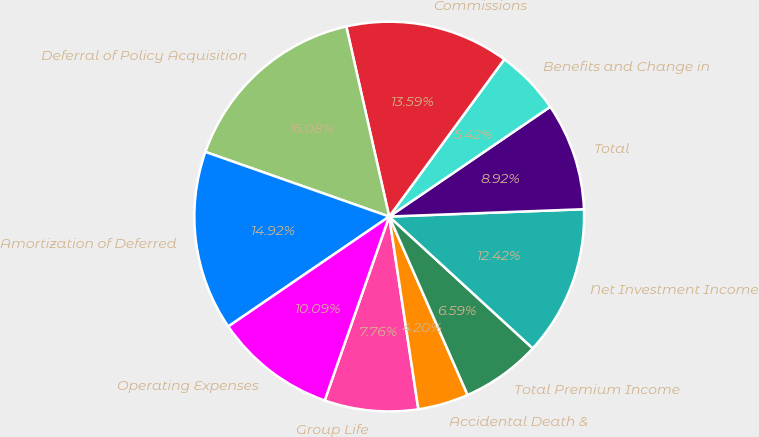Convert chart. <chart><loc_0><loc_0><loc_500><loc_500><pie_chart><fcel>Group Life<fcel>Accidental Death &<fcel>Total Premium Income<fcel>Net Investment Income<fcel>Total<fcel>Benefits and Change in<fcel>Commissions<fcel>Deferral of Policy Acquisition<fcel>Amortization of Deferred<fcel>Operating Expenses<nl><fcel>7.76%<fcel>4.2%<fcel>6.59%<fcel>12.42%<fcel>8.92%<fcel>5.42%<fcel>13.59%<fcel>16.08%<fcel>14.92%<fcel>10.09%<nl></chart> 